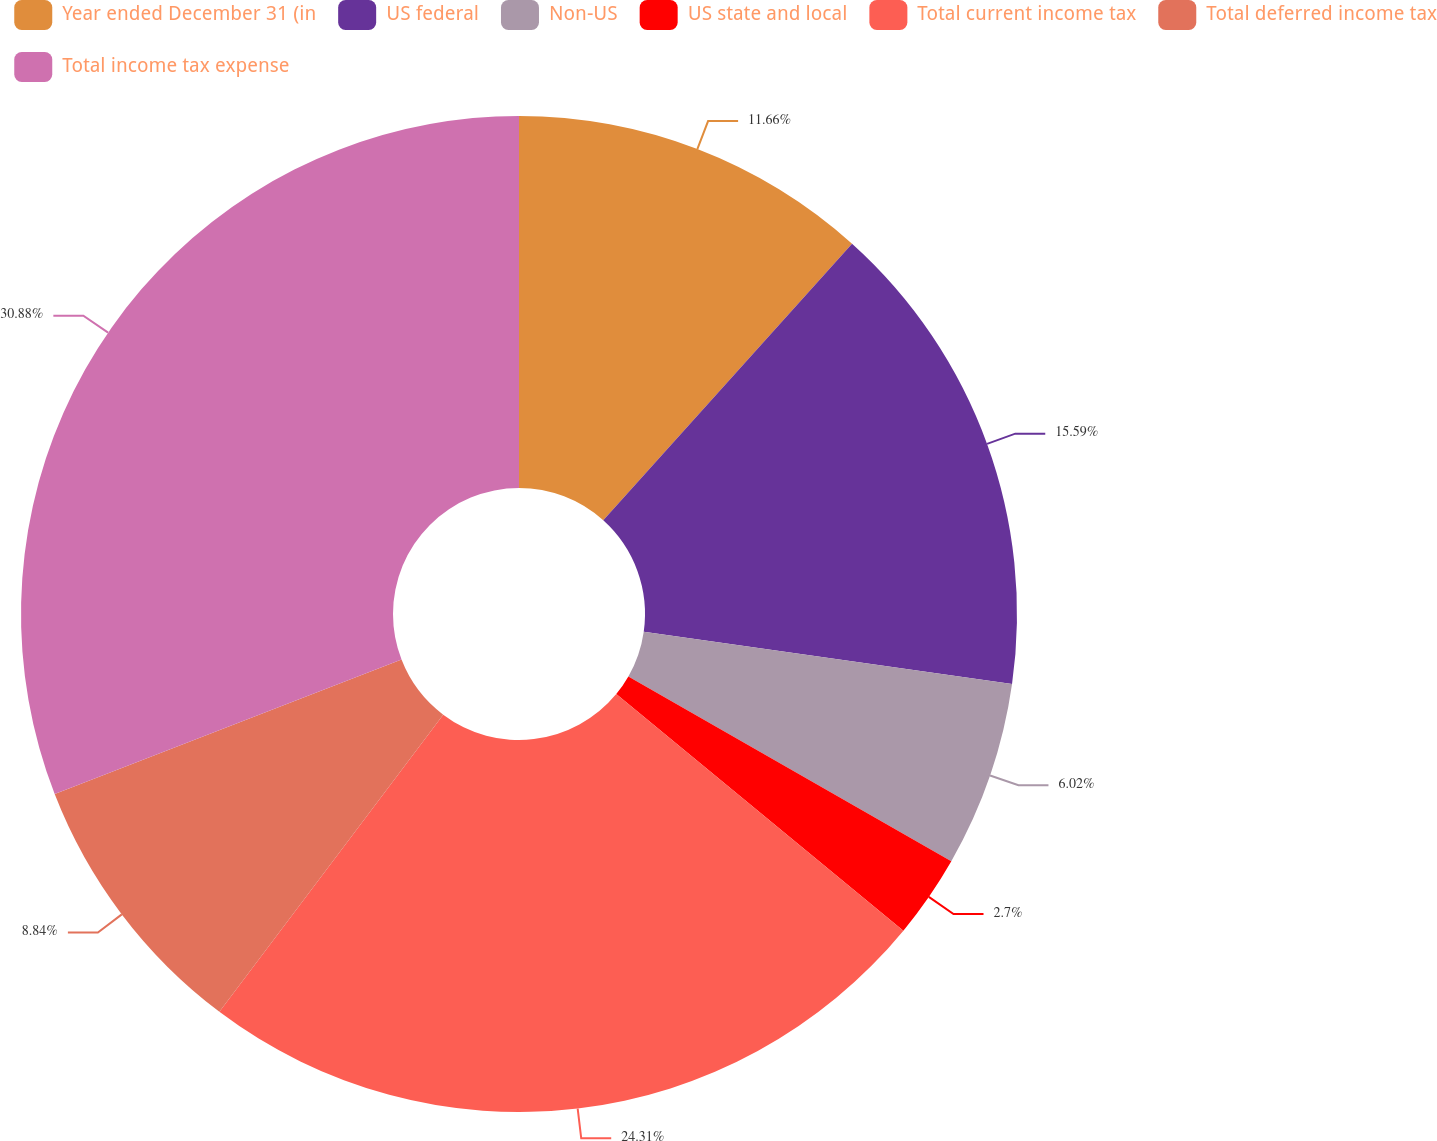<chart> <loc_0><loc_0><loc_500><loc_500><pie_chart><fcel>Year ended December 31 (in<fcel>US federal<fcel>Non-US<fcel>US state and local<fcel>Total current income tax<fcel>Total deferred income tax<fcel>Total income tax expense<nl><fcel>11.66%<fcel>15.59%<fcel>6.02%<fcel>2.7%<fcel>24.31%<fcel>8.84%<fcel>30.89%<nl></chart> 